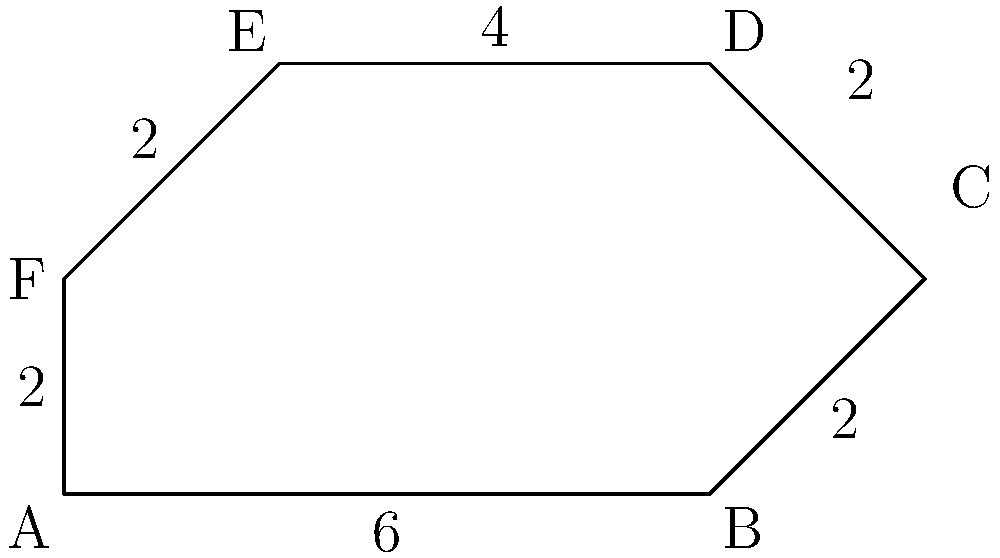The shape ABCDEF represents the boundaries of a safe online space for cyberbullying victims. Calculate the perimeter of this irregular shape given the following side lengths: AB = 6 units, BC = 2 units, CD = 2 units, DE = 4 units, EF = 2 units, and FA = 2 units. To calculate the perimeter of the irregular shape ABCDEF, we need to sum up the lengths of all its sides. Let's break it down step by step:

1. Side AB: 6 units
2. Side BC: 2 units
3. Side CD: 2 units
4. Side DE: 4 units
5. Side EF: 2 units
6. Side FA: 2 units

Now, let's add all these lengths together:

$$\text{Perimeter} = AB + BC + CD + DE + EF + FA$$
$$\text{Perimeter} = 6 + 2 + 2 + 4 + 2 + 2$$
$$\text{Perimeter} = 18 \text{ units}$$

Therefore, the perimeter of the irregular shape ABCDEF, which symbolizes the boundaries of a safe online space, is 18 units.
Answer: 18 units 